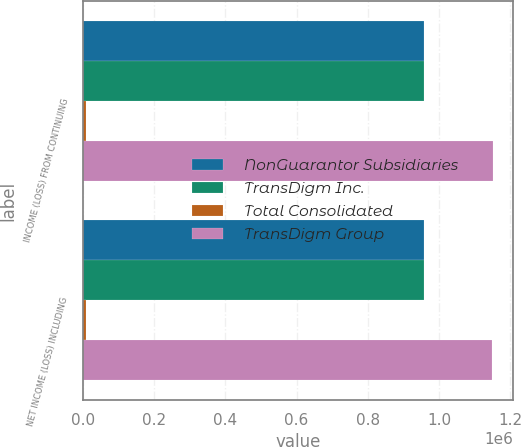Convert chart to OTSL. <chart><loc_0><loc_0><loc_500><loc_500><stacked_bar_chart><ecel><fcel>INCOME (LOSS) FROM CONTINUING<fcel>NET INCOME (LOSS) INCLUDING<nl><fcel>NonGuarantor Subsidiaries<fcel>957062<fcel>957062<nl><fcel>TransDigm Inc.<fcel>957062<fcel>957062<nl><fcel>Total Consolidated<fcel>7039<fcel>7039<nl><fcel>TransDigm Group<fcel>1.15167e+06<fcel>1.14925e+06<nl></chart> 